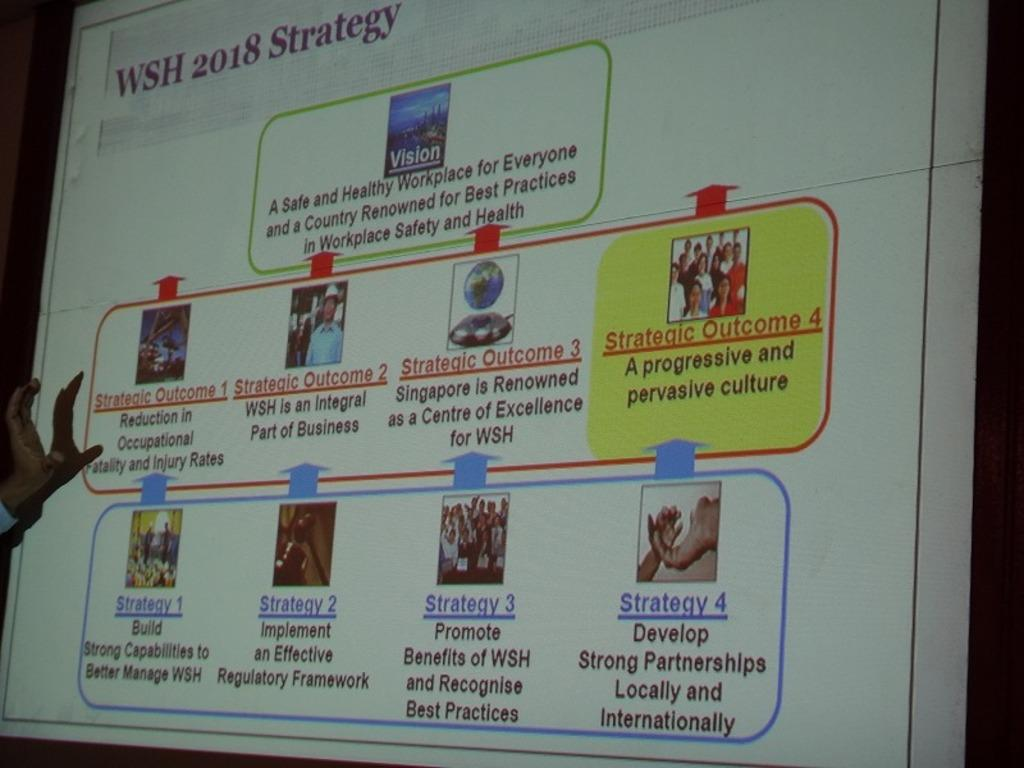Provide a one-sentence caption for the provided image. A screen showing many strategies named "WSH 2018 Strategy". 